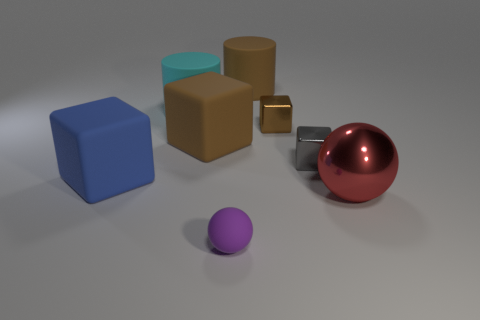Do the metallic thing in front of the gray thing and the big blue matte cube have the same size?
Offer a very short reply. Yes. How many brown things are large cylinders or rubber spheres?
Keep it short and to the point. 1. What is the tiny brown object that is behind the big metal sphere made of?
Your response must be concise. Metal. There is a brown cylinder right of the purple rubber object; how many big matte things are in front of it?
Give a very brief answer. 3. How many blue things have the same shape as the tiny gray thing?
Keep it short and to the point. 1. How many tiny metallic objects are there?
Your answer should be very brief. 2. There is a ball that is in front of the metallic sphere; what is its color?
Give a very brief answer. Purple. The object that is in front of the sphere that is behind the purple matte thing is what color?
Offer a terse response. Purple. The other rubber cylinder that is the same size as the cyan rubber cylinder is what color?
Your answer should be compact. Brown. How many rubber things are in front of the large cyan thing and behind the big red object?
Offer a terse response. 2. 